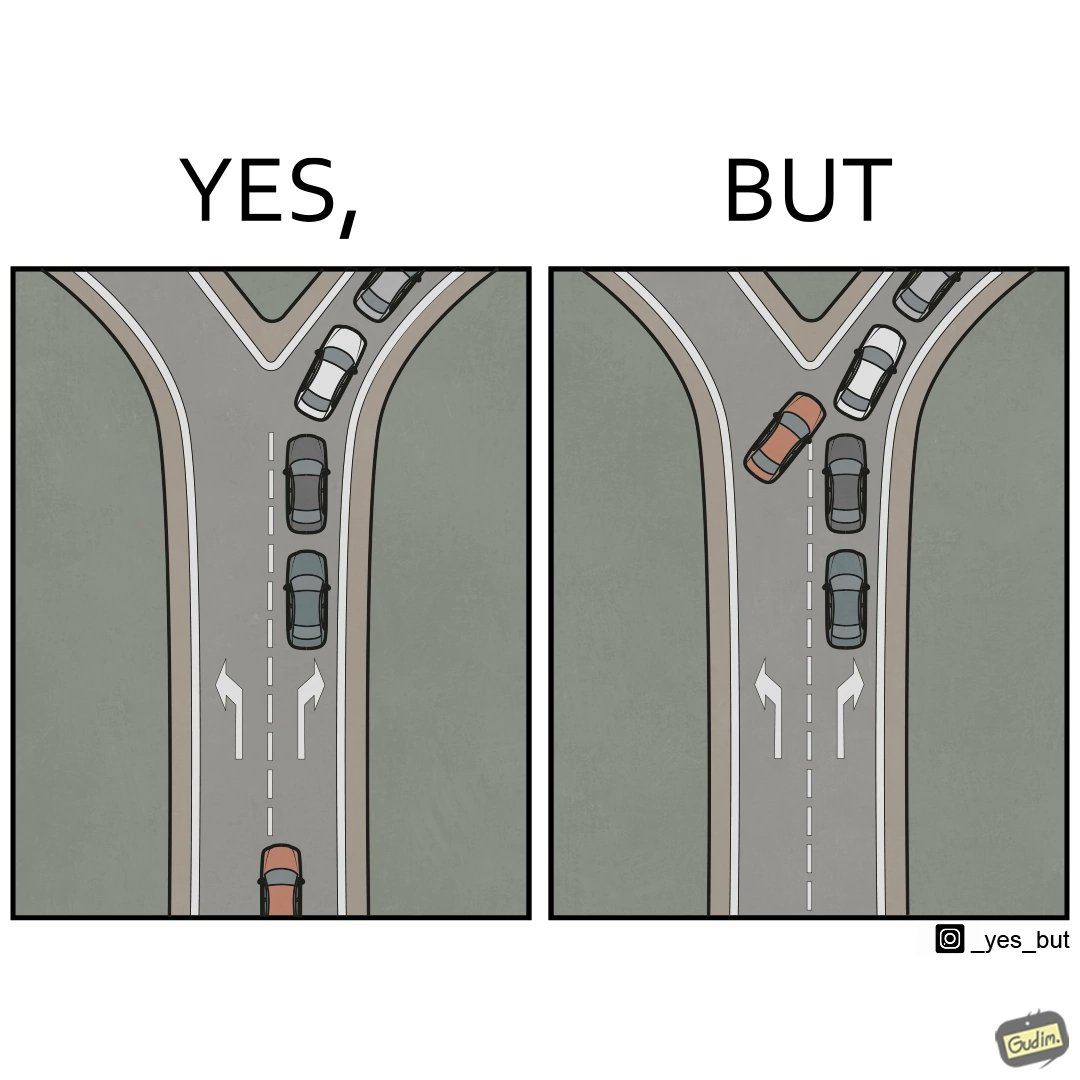Why is this image considered satirical? This image is funny, as a car is approaching a Y junction, with the left fork empty, and the right fork filled with a line of cars. If it needs to go to the right, it should get behind the line of cars. However, in an attempt to probably go faster, the car tries to cut in line, leading to more traffic,  thereby increasing commute time. 